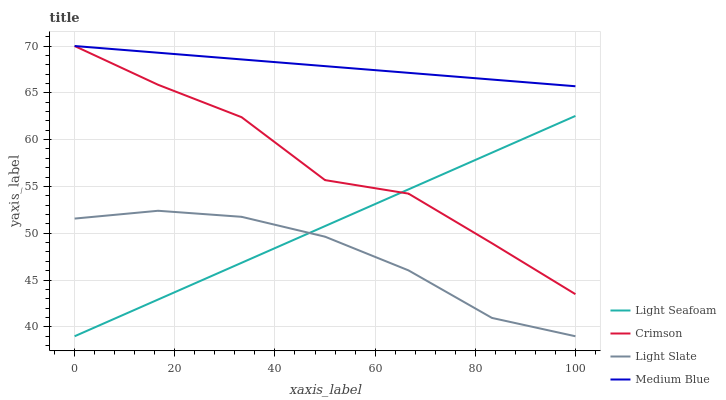Does Light Slate have the minimum area under the curve?
Answer yes or no. Yes. Does Medium Blue have the maximum area under the curve?
Answer yes or no. Yes. Does Light Seafoam have the minimum area under the curve?
Answer yes or no. No. Does Light Seafoam have the maximum area under the curve?
Answer yes or no. No. Is Light Seafoam the smoothest?
Answer yes or no. Yes. Is Crimson the roughest?
Answer yes or no. Yes. Is Light Slate the smoothest?
Answer yes or no. No. Is Light Slate the roughest?
Answer yes or no. No. Does Medium Blue have the lowest value?
Answer yes or no. No. Does Medium Blue have the highest value?
Answer yes or no. Yes. Does Light Seafoam have the highest value?
Answer yes or no. No. Is Light Slate less than Crimson?
Answer yes or no. Yes. Is Medium Blue greater than Light Slate?
Answer yes or no. Yes. Does Light Slate intersect Light Seafoam?
Answer yes or no. Yes. Is Light Slate less than Light Seafoam?
Answer yes or no. No. Is Light Slate greater than Light Seafoam?
Answer yes or no. No. Does Light Slate intersect Crimson?
Answer yes or no. No. 